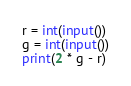Convert code to text. <code><loc_0><loc_0><loc_500><loc_500><_Python_>r = int(input())
g = int(input())
print(2 * g - r)
</code> 